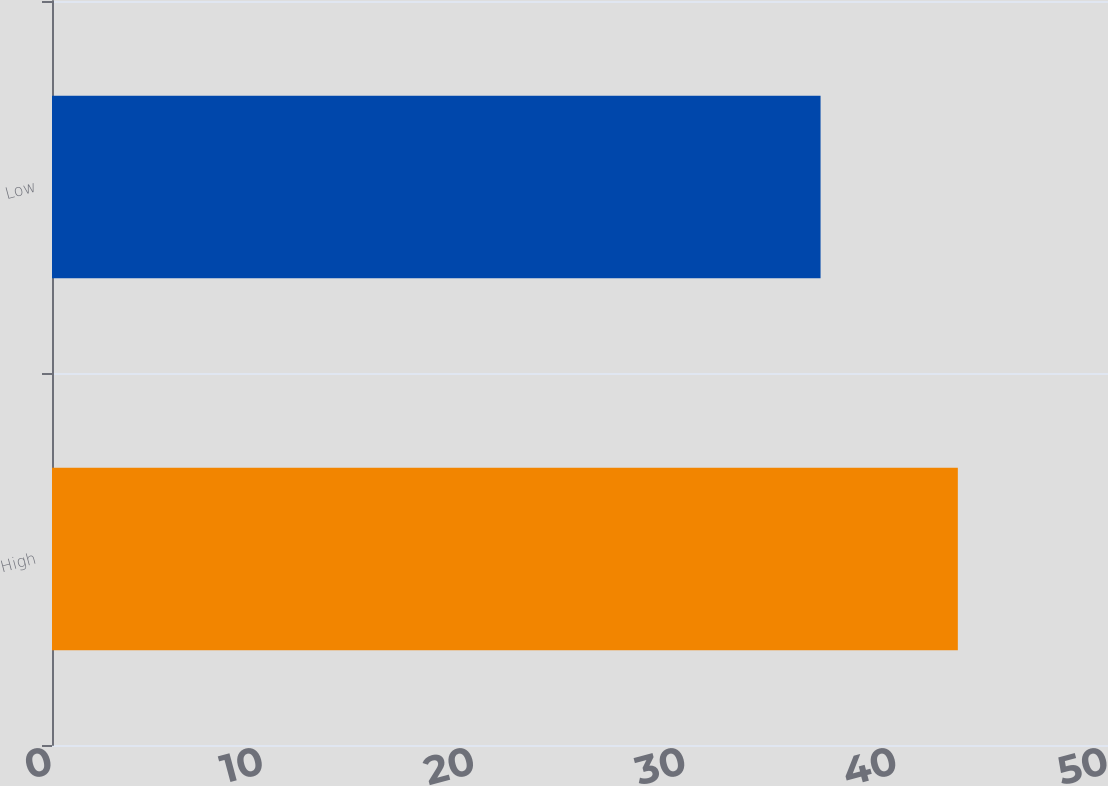Convert chart. <chart><loc_0><loc_0><loc_500><loc_500><bar_chart><fcel>High<fcel>Low<nl><fcel>42.89<fcel>36.39<nl></chart> 